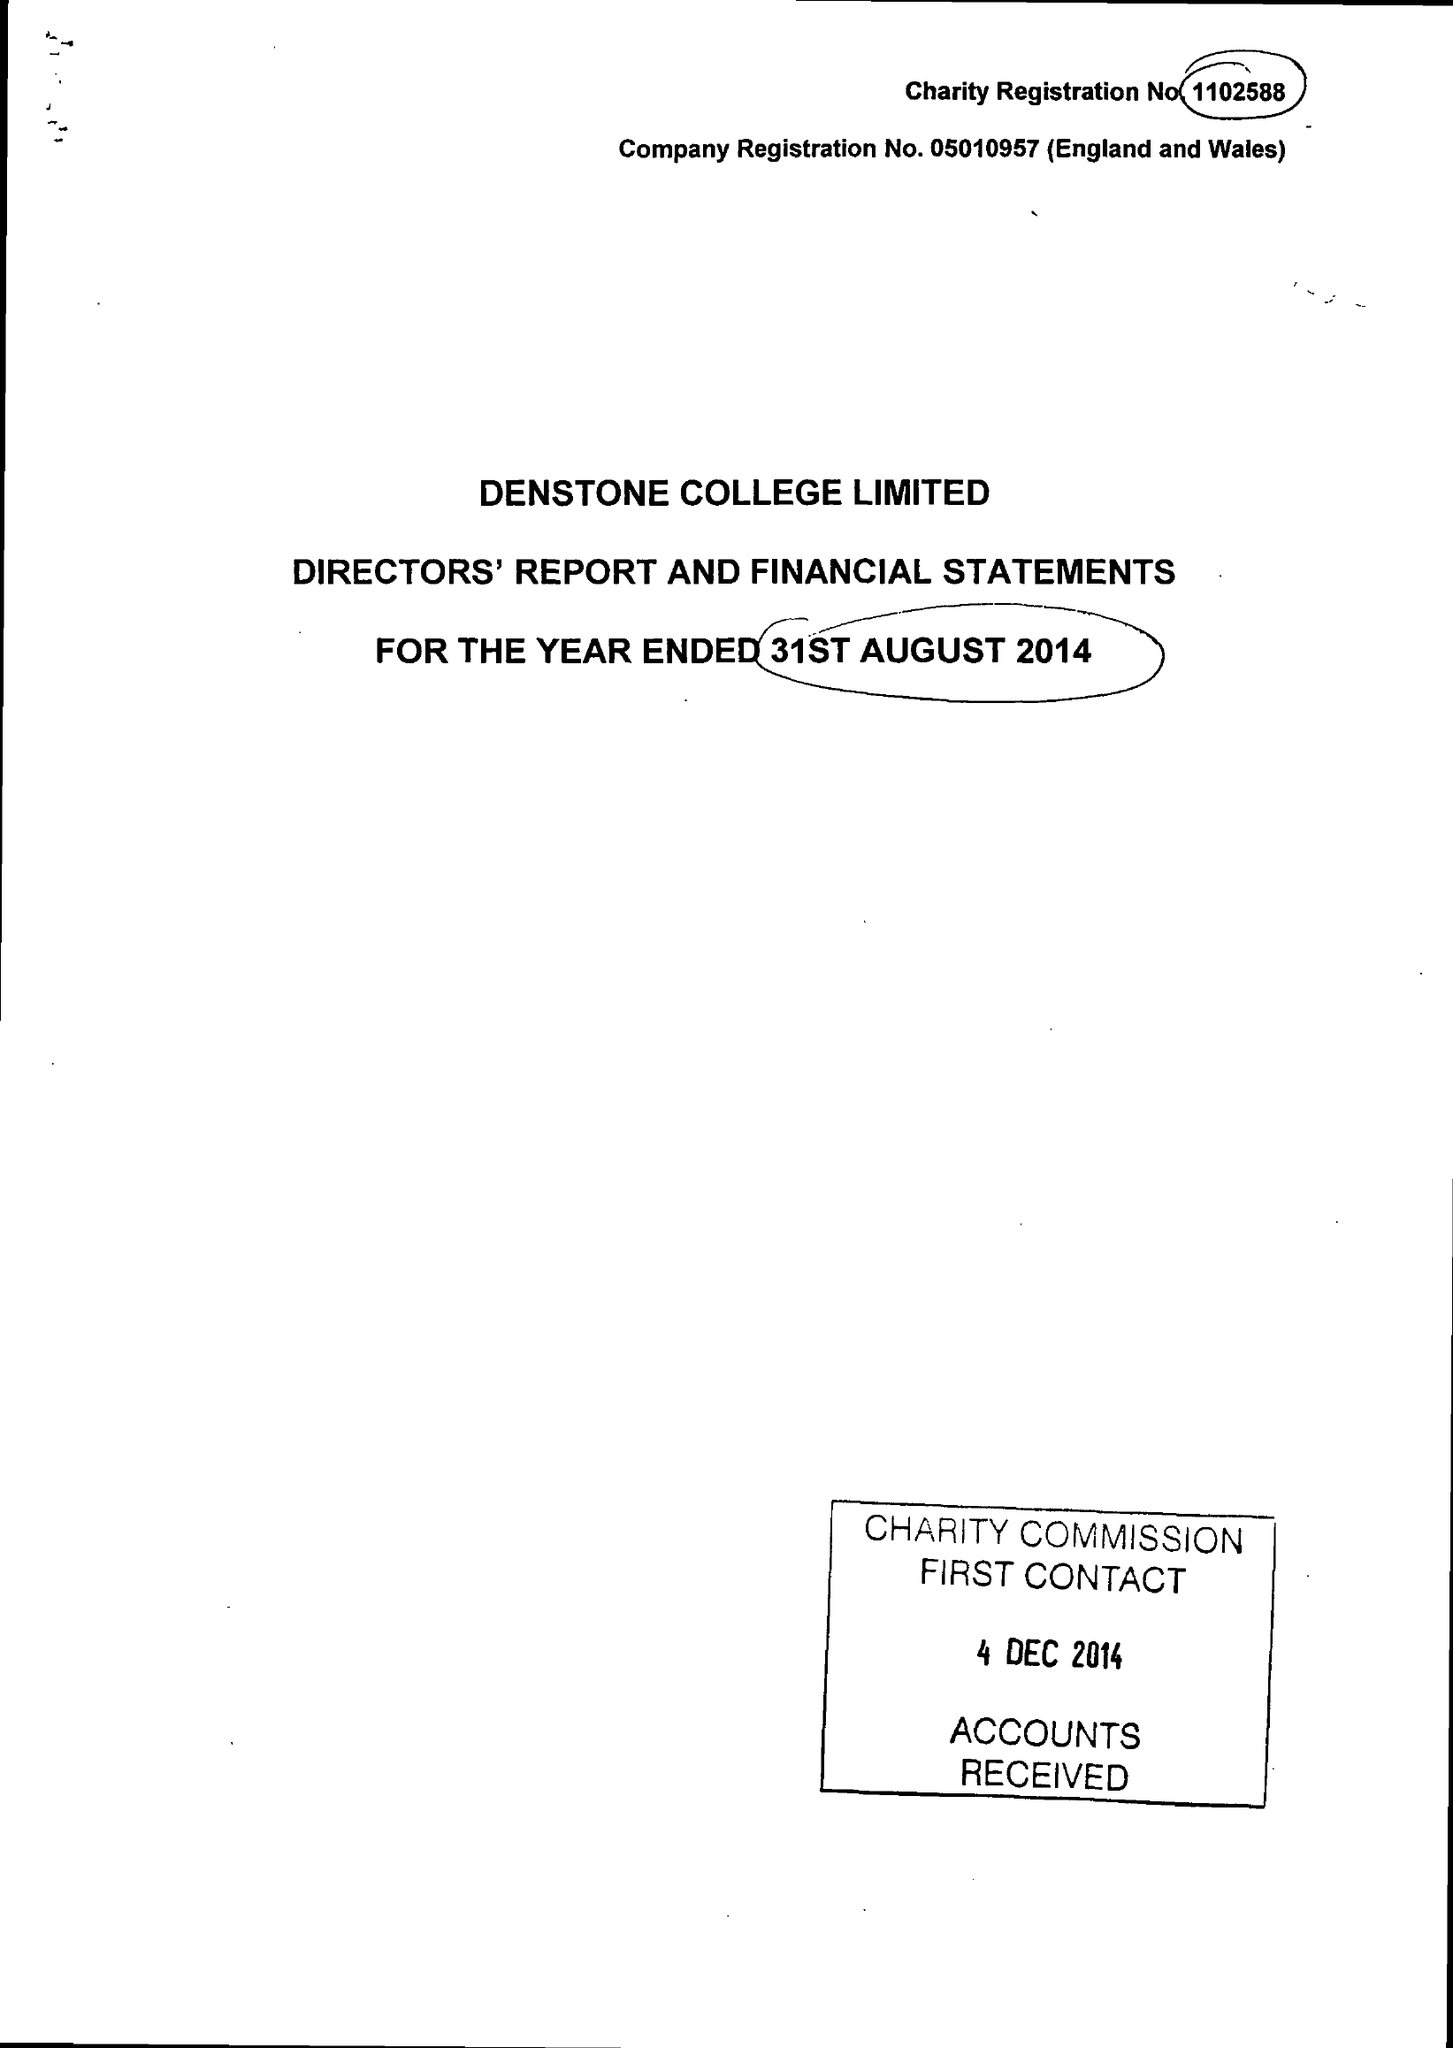What is the value for the address__street_line?
Answer the question using a single word or phrase. None 